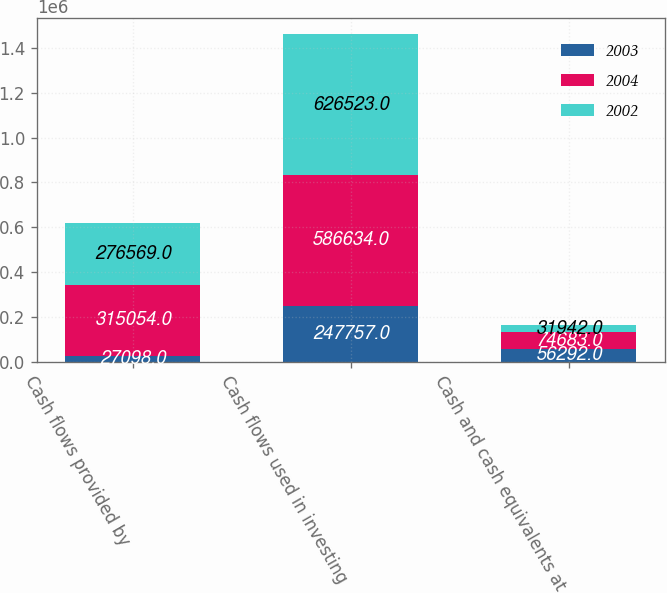Convert chart to OTSL. <chart><loc_0><loc_0><loc_500><loc_500><stacked_bar_chart><ecel><fcel>Cash flows provided by<fcel>Cash flows used in investing<fcel>Cash and cash equivalents at<nl><fcel>2003<fcel>27098<fcel>247757<fcel>56292<nl><fcel>2004<fcel>315054<fcel>586634<fcel>74683<nl><fcel>2002<fcel>276569<fcel>626523<fcel>31942<nl></chart> 